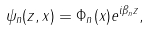<formula> <loc_0><loc_0><loc_500><loc_500>\psi _ { n } ( z , x ) = \Phi _ { n } ( x ) e ^ { i \beta _ { n } z } ,</formula> 